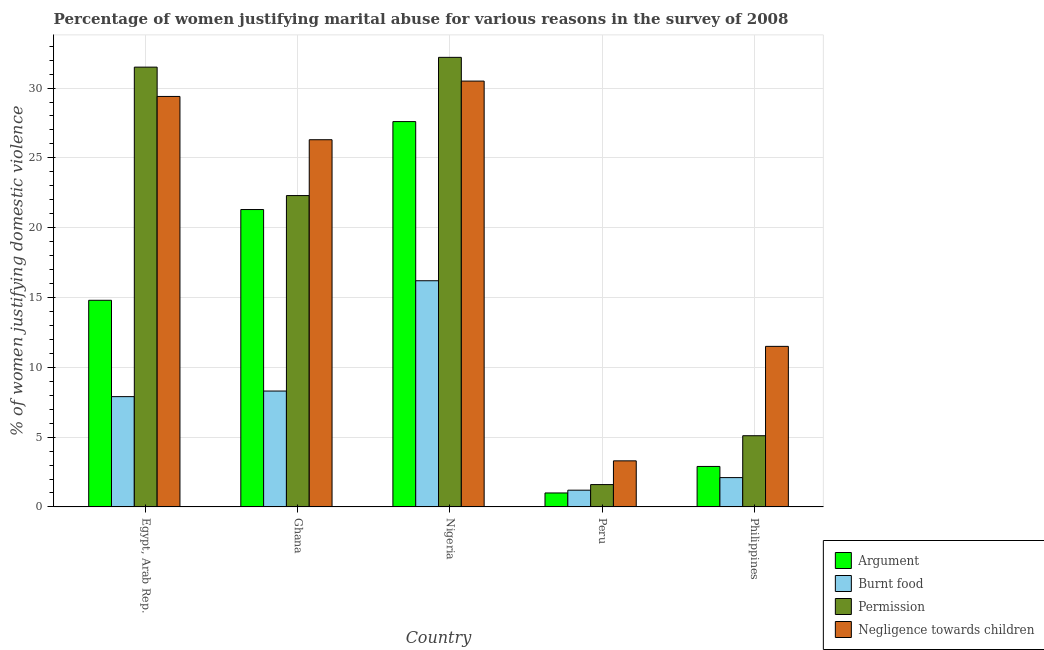Are the number of bars per tick equal to the number of legend labels?
Give a very brief answer. Yes. Are the number of bars on each tick of the X-axis equal?
Ensure brevity in your answer.  Yes. How many bars are there on the 1st tick from the right?
Offer a terse response. 4. What is the label of the 3rd group of bars from the left?
Offer a terse response. Nigeria. In how many cases, is the number of bars for a given country not equal to the number of legend labels?
Your answer should be very brief. 0. What is the percentage of women justifying abuse in the case of an argument in Nigeria?
Ensure brevity in your answer.  27.6. Across all countries, what is the maximum percentage of women justifying abuse in the case of an argument?
Your answer should be compact. 27.6. In which country was the percentage of women justifying abuse for going without permission maximum?
Keep it short and to the point. Nigeria. What is the total percentage of women justifying abuse for burning food in the graph?
Your answer should be compact. 35.7. What is the difference between the percentage of women justifying abuse for going without permission in Ghana and that in Peru?
Your response must be concise. 20.7. What is the difference between the percentage of women justifying abuse for burning food in Philippines and the percentage of women justifying abuse for showing negligence towards children in Egypt, Arab Rep.?
Give a very brief answer. -27.3. What is the average percentage of women justifying abuse for showing negligence towards children per country?
Provide a succinct answer. 20.2. What is the difference between the percentage of women justifying abuse for going without permission and percentage of women justifying abuse for burning food in Egypt, Arab Rep.?
Provide a succinct answer. 23.6. In how many countries, is the percentage of women justifying abuse in the case of an argument greater than 25 %?
Your answer should be very brief. 1. What is the ratio of the percentage of women justifying abuse for going without permission in Egypt, Arab Rep. to that in Philippines?
Your answer should be compact. 6.18. Is the percentage of women justifying abuse for burning food in Nigeria less than that in Philippines?
Make the answer very short. No. What is the difference between the highest and the second highest percentage of women justifying abuse in the case of an argument?
Provide a short and direct response. 6.3. What is the difference between the highest and the lowest percentage of women justifying abuse for showing negligence towards children?
Ensure brevity in your answer.  27.2. Is it the case that in every country, the sum of the percentage of women justifying abuse for showing negligence towards children and percentage of women justifying abuse for burning food is greater than the sum of percentage of women justifying abuse for going without permission and percentage of women justifying abuse in the case of an argument?
Offer a terse response. No. What does the 2nd bar from the left in Ghana represents?
Ensure brevity in your answer.  Burnt food. What does the 2nd bar from the right in Egypt, Arab Rep. represents?
Provide a succinct answer. Permission. Is it the case that in every country, the sum of the percentage of women justifying abuse in the case of an argument and percentage of women justifying abuse for burning food is greater than the percentage of women justifying abuse for going without permission?
Provide a short and direct response. No. Are all the bars in the graph horizontal?
Keep it short and to the point. No. How many countries are there in the graph?
Your response must be concise. 5. Does the graph contain grids?
Your answer should be very brief. Yes. Where does the legend appear in the graph?
Give a very brief answer. Bottom right. What is the title of the graph?
Provide a succinct answer. Percentage of women justifying marital abuse for various reasons in the survey of 2008. Does "Third 20% of population" appear as one of the legend labels in the graph?
Offer a very short reply. No. What is the label or title of the Y-axis?
Offer a terse response. % of women justifying domestic violence. What is the % of women justifying domestic violence in Permission in Egypt, Arab Rep.?
Your answer should be compact. 31.5. What is the % of women justifying domestic violence in Negligence towards children in Egypt, Arab Rep.?
Keep it short and to the point. 29.4. What is the % of women justifying domestic violence of Argument in Ghana?
Give a very brief answer. 21.3. What is the % of women justifying domestic violence in Permission in Ghana?
Provide a succinct answer. 22.3. What is the % of women justifying domestic violence of Negligence towards children in Ghana?
Offer a very short reply. 26.3. What is the % of women justifying domestic violence of Argument in Nigeria?
Your answer should be very brief. 27.6. What is the % of women justifying domestic violence of Burnt food in Nigeria?
Keep it short and to the point. 16.2. What is the % of women justifying domestic violence of Permission in Nigeria?
Your answer should be very brief. 32.2. What is the % of women justifying domestic violence of Negligence towards children in Nigeria?
Ensure brevity in your answer.  30.5. What is the % of women justifying domestic violence of Argument in Peru?
Provide a short and direct response. 1. What is the % of women justifying domestic violence of Burnt food in Peru?
Offer a terse response. 1.2. What is the % of women justifying domestic violence in Burnt food in Philippines?
Your answer should be very brief. 2.1. What is the % of women justifying domestic violence in Permission in Philippines?
Provide a succinct answer. 5.1. What is the % of women justifying domestic violence in Negligence towards children in Philippines?
Keep it short and to the point. 11.5. Across all countries, what is the maximum % of women justifying domestic violence of Argument?
Your answer should be compact. 27.6. Across all countries, what is the maximum % of women justifying domestic violence in Burnt food?
Provide a succinct answer. 16.2. Across all countries, what is the maximum % of women justifying domestic violence of Permission?
Make the answer very short. 32.2. Across all countries, what is the maximum % of women justifying domestic violence of Negligence towards children?
Provide a succinct answer. 30.5. Across all countries, what is the minimum % of women justifying domestic violence in Argument?
Your response must be concise. 1. Across all countries, what is the minimum % of women justifying domestic violence in Burnt food?
Give a very brief answer. 1.2. Across all countries, what is the minimum % of women justifying domestic violence of Negligence towards children?
Give a very brief answer. 3.3. What is the total % of women justifying domestic violence of Argument in the graph?
Provide a succinct answer. 67.6. What is the total % of women justifying domestic violence of Burnt food in the graph?
Ensure brevity in your answer.  35.7. What is the total % of women justifying domestic violence of Permission in the graph?
Keep it short and to the point. 92.7. What is the total % of women justifying domestic violence of Negligence towards children in the graph?
Keep it short and to the point. 101. What is the difference between the % of women justifying domestic violence of Argument in Egypt, Arab Rep. and that in Ghana?
Provide a succinct answer. -6.5. What is the difference between the % of women justifying domestic violence in Permission in Egypt, Arab Rep. and that in Ghana?
Offer a terse response. 9.2. What is the difference between the % of women justifying domestic violence in Permission in Egypt, Arab Rep. and that in Nigeria?
Make the answer very short. -0.7. What is the difference between the % of women justifying domestic violence of Negligence towards children in Egypt, Arab Rep. and that in Nigeria?
Your response must be concise. -1.1. What is the difference between the % of women justifying domestic violence in Permission in Egypt, Arab Rep. and that in Peru?
Your answer should be very brief. 29.9. What is the difference between the % of women justifying domestic violence in Negligence towards children in Egypt, Arab Rep. and that in Peru?
Your answer should be compact. 26.1. What is the difference between the % of women justifying domestic violence in Argument in Egypt, Arab Rep. and that in Philippines?
Your answer should be very brief. 11.9. What is the difference between the % of women justifying domestic violence in Permission in Egypt, Arab Rep. and that in Philippines?
Provide a succinct answer. 26.4. What is the difference between the % of women justifying domestic violence in Negligence towards children in Egypt, Arab Rep. and that in Philippines?
Provide a succinct answer. 17.9. What is the difference between the % of women justifying domestic violence in Argument in Ghana and that in Peru?
Offer a very short reply. 20.3. What is the difference between the % of women justifying domestic violence in Permission in Ghana and that in Peru?
Offer a very short reply. 20.7. What is the difference between the % of women justifying domestic violence in Negligence towards children in Ghana and that in Peru?
Provide a succinct answer. 23. What is the difference between the % of women justifying domestic violence in Argument in Ghana and that in Philippines?
Give a very brief answer. 18.4. What is the difference between the % of women justifying domestic violence of Burnt food in Ghana and that in Philippines?
Give a very brief answer. 6.2. What is the difference between the % of women justifying domestic violence in Permission in Ghana and that in Philippines?
Ensure brevity in your answer.  17.2. What is the difference between the % of women justifying domestic violence of Negligence towards children in Ghana and that in Philippines?
Your response must be concise. 14.8. What is the difference between the % of women justifying domestic violence in Argument in Nigeria and that in Peru?
Your answer should be very brief. 26.6. What is the difference between the % of women justifying domestic violence in Permission in Nigeria and that in Peru?
Provide a succinct answer. 30.6. What is the difference between the % of women justifying domestic violence of Negligence towards children in Nigeria and that in Peru?
Offer a very short reply. 27.2. What is the difference between the % of women justifying domestic violence of Argument in Nigeria and that in Philippines?
Your answer should be very brief. 24.7. What is the difference between the % of women justifying domestic violence in Burnt food in Nigeria and that in Philippines?
Your answer should be compact. 14.1. What is the difference between the % of women justifying domestic violence of Permission in Nigeria and that in Philippines?
Provide a succinct answer. 27.1. What is the difference between the % of women justifying domestic violence of Argument in Peru and that in Philippines?
Make the answer very short. -1.9. What is the difference between the % of women justifying domestic violence of Argument in Egypt, Arab Rep. and the % of women justifying domestic violence of Negligence towards children in Ghana?
Your answer should be compact. -11.5. What is the difference between the % of women justifying domestic violence in Burnt food in Egypt, Arab Rep. and the % of women justifying domestic violence in Permission in Ghana?
Provide a short and direct response. -14.4. What is the difference between the % of women justifying domestic violence in Burnt food in Egypt, Arab Rep. and the % of women justifying domestic violence in Negligence towards children in Ghana?
Make the answer very short. -18.4. What is the difference between the % of women justifying domestic violence in Permission in Egypt, Arab Rep. and the % of women justifying domestic violence in Negligence towards children in Ghana?
Your response must be concise. 5.2. What is the difference between the % of women justifying domestic violence in Argument in Egypt, Arab Rep. and the % of women justifying domestic violence in Permission in Nigeria?
Offer a very short reply. -17.4. What is the difference between the % of women justifying domestic violence of Argument in Egypt, Arab Rep. and the % of women justifying domestic violence of Negligence towards children in Nigeria?
Give a very brief answer. -15.7. What is the difference between the % of women justifying domestic violence of Burnt food in Egypt, Arab Rep. and the % of women justifying domestic violence of Permission in Nigeria?
Offer a terse response. -24.3. What is the difference between the % of women justifying domestic violence in Burnt food in Egypt, Arab Rep. and the % of women justifying domestic violence in Negligence towards children in Nigeria?
Ensure brevity in your answer.  -22.6. What is the difference between the % of women justifying domestic violence of Argument in Egypt, Arab Rep. and the % of women justifying domestic violence of Burnt food in Peru?
Make the answer very short. 13.6. What is the difference between the % of women justifying domestic violence in Argument in Egypt, Arab Rep. and the % of women justifying domestic violence in Permission in Peru?
Give a very brief answer. 13.2. What is the difference between the % of women justifying domestic violence in Burnt food in Egypt, Arab Rep. and the % of women justifying domestic violence in Negligence towards children in Peru?
Give a very brief answer. 4.6. What is the difference between the % of women justifying domestic violence in Permission in Egypt, Arab Rep. and the % of women justifying domestic violence in Negligence towards children in Peru?
Offer a very short reply. 28.2. What is the difference between the % of women justifying domestic violence in Argument in Egypt, Arab Rep. and the % of women justifying domestic violence in Permission in Philippines?
Your answer should be very brief. 9.7. What is the difference between the % of women justifying domestic violence of Argument in Egypt, Arab Rep. and the % of women justifying domestic violence of Negligence towards children in Philippines?
Offer a very short reply. 3.3. What is the difference between the % of women justifying domestic violence in Burnt food in Egypt, Arab Rep. and the % of women justifying domestic violence in Permission in Philippines?
Give a very brief answer. 2.8. What is the difference between the % of women justifying domestic violence of Burnt food in Egypt, Arab Rep. and the % of women justifying domestic violence of Negligence towards children in Philippines?
Offer a terse response. -3.6. What is the difference between the % of women justifying domestic violence of Permission in Egypt, Arab Rep. and the % of women justifying domestic violence of Negligence towards children in Philippines?
Keep it short and to the point. 20. What is the difference between the % of women justifying domestic violence in Argument in Ghana and the % of women justifying domestic violence in Burnt food in Nigeria?
Give a very brief answer. 5.1. What is the difference between the % of women justifying domestic violence in Argument in Ghana and the % of women justifying domestic violence in Permission in Nigeria?
Ensure brevity in your answer.  -10.9. What is the difference between the % of women justifying domestic violence of Burnt food in Ghana and the % of women justifying domestic violence of Permission in Nigeria?
Give a very brief answer. -23.9. What is the difference between the % of women justifying domestic violence of Burnt food in Ghana and the % of women justifying domestic violence of Negligence towards children in Nigeria?
Your answer should be compact. -22.2. What is the difference between the % of women justifying domestic violence of Argument in Ghana and the % of women justifying domestic violence of Burnt food in Peru?
Offer a very short reply. 20.1. What is the difference between the % of women justifying domestic violence of Argument in Ghana and the % of women justifying domestic violence of Permission in Peru?
Give a very brief answer. 19.7. What is the difference between the % of women justifying domestic violence of Burnt food in Ghana and the % of women justifying domestic violence of Negligence towards children in Peru?
Ensure brevity in your answer.  5. What is the difference between the % of women justifying domestic violence of Permission in Ghana and the % of women justifying domestic violence of Negligence towards children in Peru?
Provide a short and direct response. 19. What is the difference between the % of women justifying domestic violence of Argument in Ghana and the % of women justifying domestic violence of Negligence towards children in Philippines?
Provide a succinct answer. 9.8. What is the difference between the % of women justifying domestic violence in Burnt food in Ghana and the % of women justifying domestic violence in Permission in Philippines?
Give a very brief answer. 3.2. What is the difference between the % of women justifying domestic violence of Argument in Nigeria and the % of women justifying domestic violence of Burnt food in Peru?
Your answer should be very brief. 26.4. What is the difference between the % of women justifying domestic violence of Argument in Nigeria and the % of women justifying domestic violence of Permission in Peru?
Your answer should be very brief. 26. What is the difference between the % of women justifying domestic violence in Argument in Nigeria and the % of women justifying domestic violence in Negligence towards children in Peru?
Give a very brief answer. 24.3. What is the difference between the % of women justifying domestic violence in Burnt food in Nigeria and the % of women justifying domestic violence in Negligence towards children in Peru?
Your answer should be very brief. 12.9. What is the difference between the % of women justifying domestic violence of Permission in Nigeria and the % of women justifying domestic violence of Negligence towards children in Peru?
Your response must be concise. 28.9. What is the difference between the % of women justifying domestic violence of Argument in Nigeria and the % of women justifying domestic violence of Permission in Philippines?
Offer a terse response. 22.5. What is the difference between the % of women justifying domestic violence of Argument in Nigeria and the % of women justifying domestic violence of Negligence towards children in Philippines?
Provide a short and direct response. 16.1. What is the difference between the % of women justifying domestic violence in Permission in Nigeria and the % of women justifying domestic violence in Negligence towards children in Philippines?
Keep it short and to the point. 20.7. What is the difference between the % of women justifying domestic violence in Argument in Peru and the % of women justifying domestic violence in Burnt food in Philippines?
Your response must be concise. -1.1. What is the difference between the % of women justifying domestic violence of Burnt food in Peru and the % of women justifying domestic violence of Negligence towards children in Philippines?
Offer a very short reply. -10.3. What is the average % of women justifying domestic violence of Argument per country?
Offer a terse response. 13.52. What is the average % of women justifying domestic violence of Burnt food per country?
Your answer should be very brief. 7.14. What is the average % of women justifying domestic violence of Permission per country?
Ensure brevity in your answer.  18.54. What is the average % of women justifying domestic violence in Negligence towards children per country?
Ensure brevity in your answer.  20.2. What is the difference between the % of women justifying domestic violence in Argument and % of women justifying domestic violence in Burnt food in Egypt, Arab Rep.?
Your answer should be compact. 6.9. What is the difference between the % of women justifying domestic violence of Argument and % of women justifying domestic violence of Permission in Egypt, Arab Rep.?
Provide a succinct answer. -16.7. What is the difference between the % of women justifying domestic violence in Argument and % of women justifying domestic violence in Negligence towards children in Egypt, Arab Rep.?
Provide a short and direct response. -14.6. What is the difference between the % of women justifying domestic violence in Burnt food and % of women justifying domestic violence in Permission in Egypt, Arab Rep.?
Your answer should be compact. -23.6. What is the difference between the % of women justifying domestic violence of Burnt food and % of women justifying domestic violence of Negligence towards children in Egypt, Arab Rep.?
Give a very brief answer. -21.5. What is the difference between the % of women justifying domestic violence of Argument and % of women justifying domestic violence of Permission in Ghana?
Provide a short and direct response. -1. What is the difference between the % of women justifying domestic violence in Argument and % of women justifying domestic violence in Negligence towards children in Ghana?
Provide a succinct answer. -5. What is the difference between the % of women justifying domestic violence of Burnt food and % of women justifying domestic violence of Negligence towards children in Ghana?
Ensure brevity in your answer.  -18. What is the difference between the % of women justifying domestic violence in Argument and % of women justifying domestic violence in Negligence towards children in Nigeria?
Offer a terse response. -2.9. What is the difference between the % of women justifying domestic violence in Burnt food and % of women justifying domestic violence in Permission in Nigeria?
Provide a short and direct response. -16. What is the difference between the % of women justifying domestic violence in Burnt food and % of women justifying domestic violence in Negligence towards children in Nigeria?
Your answer should be compact. -14.3. What is the difference between the % of women justifying domestic violence in Permission and % of women justifying domestic violence in Negligence towards children in Nigeria?
Make the answer very short. 1.7. What is the difference between the % of women justifying domestic violence in Argument and % of women justifying domestic violence in Burnt food in Peru?
Provide a succinct answer. -0.2. What is the difference between the % of women justifying domestic violence of Argument and % of women justifying domestic violence of Permission in Peru?
Offer a terse response. -0.6. What is the difference between the % of women justifying domestic violence in Argument and % of women justifying domestic violence in Negligence towards children in Peru?
Keep it short and to the point. -2.3. What is the difference between the % of women justifying domestic violence of Burnt food and % of women justifying domestic violence of Negligence towards children in Peru?
Make the answer very short. -2.1. What is the difference between the % of women justifying domestic violence of Permission and % of women justifying domestic violence of Negligence towards children in Peru?
Give a very brief answer. -1.7. What is the difference between the % of women justifying domestic violence in Argument and % of women justifying domestic violence in Burnt food in Philippines?
Your response must be concise. 0.8. What is the difference between the % of women justifying domestic violence of Argument and % of women justifying domestic violence of Permission in Philippines?
Offer a terse response. -2.2. What is the difference between the % of women justifying domestic violence of Permission and % of women justifying domestic violence of Negligence towards children in Philippines?
Your answer should be compact. -6.4. What is the ratio of the % of women justifying domestic violence of Argument in Egypt, Arab Rep. to that in Ghana?
Provide a succinct answer. 0.69. What is the ratio of the % of women justifying domestic violence of Burnt food in Egypt, Arab Rep. to that in Ghana?
Offer a terse response. 0.95. What is the ratio of the % of women justifying domestic violence of Permission in Egypt, Arab Rep. to that in Ghana?
Your answer should be compact. 1.41. What is the ratio of the % of women justifying domestic violence in Negligence towards children in Egypt, Arab Rep. to that in Ghana?
Your answer should be very brief. 1.12. What is the ratio of the % of women justifying domestic violence of Argument in Egypt, Arab Rep. to that in Nigeria?
Ensure brevity in your answer.  0.54. What is the ratio of the % of women justifying domestic violence of Burnt food in Egypt, Arab Rep. to that in Nigeria?
Offer a terse response. 0.49. What is the ratio of the % of women justifying domestic violence in Permission in Egypt, Arab Rep. to that in Nigeria?
Give a very brief answer. 0.98. What is the ratio of the % of women justifying domestic violence in Negligence towards children in Egypt, Arab Rep. to that in Nigeria?
Offer a terse response. 0.96. What is the ratio of the % of women justifying domestic violence in Argument in Egypt, Arab Rep. to that in Peru?
Your answer should be compact. 14.8. What is the ratio of the % of women justifying domestic violence of Burnt food in Egypt, Arab Rep. to that in Peru?
Give a very brief answer. 6.58. What is the ratio of the % of women justifying domestic violence of Permission in Egypt, Arab Rep. to that in Peru?
Your response must be concise. 19.69. What is the ratio of the % of women justifying domestic violence of Negligence towards children in Egypt, Arab Rep. to that in Peru?
Your answer should be very brief. 8.91. What is the ratio of the % of women justifying domestic violence in Argument in Egypt, Arab Rep. to that in Philippines?
Your answer should be very brief. 5.1. What is the ratio of the % of women justifying domestic violence in Burnt food in Egypt, Arab Rep. to that in Philippines?
Provide a succinct answer. 3.76. What is the ratio of the % of women justifying domestic violence in Permission in Egypt, Arab Rep. to that in Philippines?
Give a very brief answer. 6.18. What is the ratio of the % of women justifying domestic violence of Negligence towards children in Egypt, Arab Rep. to that in Philippines?
Ensure brevity in your answer.  2.56. What is the ratio of the % of women justifying domestic violence in Argument in Ghana to that in Nigeria?
Provide a succinct answer. 0.77. What is the ratio of the % of women justifying domestic violence in Burnt food in Ghana to that in Nigeria?
Offer a terse response. 0.51. What is the ratio of the % of women justifying domestic violence of Permission in Ghana to that in Nigeria?
Your response must be concise. 0.69. What is the ratio of the % of women justifying domestic violence of Negligence towards children in Ghana to that in Nigeria?
Ensure brevity in your answer.  0.86. What is the ratio of the % of women justifying domestic violence in Argument in Ghana to that in Peru?
Keep it short and to the point. 21.3. What is the ratio of the % of women justifying domestic violence of Burnt food in Ghana to that in Peru?
Offer a terse response. 6.92. What is the ratio of the % of women justifying domestic violence of Permission in Ghana to that in Peru?
Your answer should be very brief. 13.94. What is the ratio of the % of women justifying domestic violence in Negligence towards children in Ghana to that in Peru?
Provide a short and direct response. 7.97. What is the ratio of the % of women justifying domestic violence in Argument in Ghana to that in Philippines?
Your answer should be compact. 7.34. What is the ratio of the % of women justifying domestic violence of Burnt food in Ghana to that in Philippines?
Your answer should be very brief. 3.95. What is the ratio of the % of women justifying domestic violence in Permission in Ghana to that in Philippines?
Your answer should be compact. 4.37. What is the ratio of the % of women justifying domestic violence in Negligence towards children in Ghana to that in Philippines?
Your answer should be compact. 2.29. What is the ratio of the % of women justifying domestic violence of Argument in Nigeria to that in Peru?
Provide a short and direct response. 27.6. What is the ratio of the % of women justifying domestic violence in Permission in Nigeria to that in Peru?
Give a very brief answer. 20.12. What is the ratio of the % of women justifying domestic violence of Negligence towards children in Nigeria to that in Peru?
Your response must be concise. 9.24. What is the ratio of the % of women justifying domestic violence of Argument in Nigeria to that in Philippines?
Make the answer very short. 9.52. What is the ratio of the % of women justifying domestic violence of Burnt food in Nigeria to that in Philippines?
Offer a very short reply. 7.71. What is the ratio of the % of women justifying domestic violence in Permission in Nigeria to that in Philippines?
Make the answer very short. 6.31. What is the ratio of the % of women justifying domestic violence of Negligence towards children in Nigeria to that in Philippines?
Keep it short and to the point. 2.65. What is the ratio of the % of women justifying domestic violence of Argument in Peru to that in Philippines?
Provide a succinct answer. 0.34. What is the ratio of the % of women justifying domestic violence in Burnt food in Peru to that in Philippines?
Your answer should be very brief. 0.57. What is the ratio of the % of women justifying domestic violence in Permission in Peru to that in Philippines?
Give a very brief answer. 0.31. What is the ratio of the % of women justifying domestic violence of Negligence towards children in Peru to that in Philippines?
Offer a very short reply. 0.29. What is the difference between the highest and the second highest % of women justifying domestic violence in Argument?
Give a very brief answer. 6.3. What is the difference between the highest and the second highest % of women justifying domestic violence of Burnt food?
Provide a succinct answer. 7.9. What is the difference between the highest and the second highest % of women justifying domestic violence of Permission?
Keep it short and to the point. 0.7. What is the difference between the highest and the lowest % of women justifying domestic violence in Argument?
Provide a succinct answer. 26.6. What is the difference between the highest and the lowest % of women justifying domestic violence in Permission?
Make the answer very short. 30.6. What is the difference between the highest and the lowest % of women justifying domestic violence of Negligence towards children?
Offer a very short reply. 27.2. 